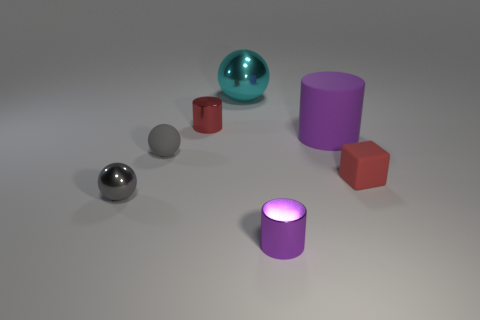Add 2 cyan objects. How many objects exist? 9 Subtract all blocks. How many objects are left? 6 Add 7 tiny rubber cubes. How many tiny rubber cubes exist? 8 Subtract 1 purple cylinders. How many objects are left? 6 Subtract all blue matte cylinders. Subtract all metallic objects. How many objects are left? 3 Add 2 small gray matte balls. How many small gray matte balls are left? 3 